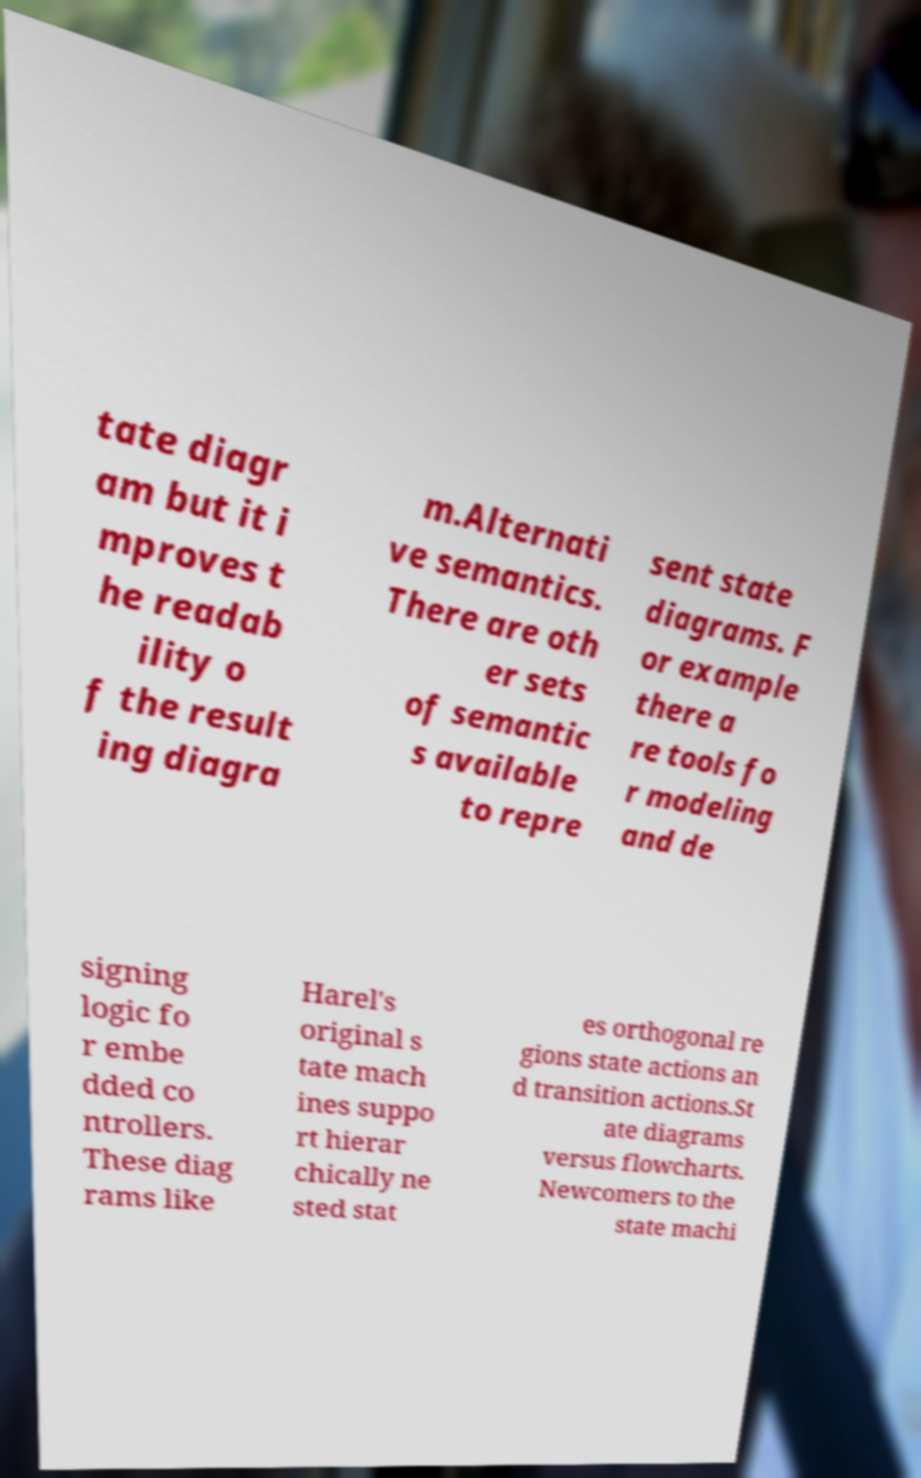For documentation purposes, I need the text within this image transcribed. Could you provide that? tate diagr am but it i mproves t he readab ility o f the result ing diagra m.Alternati ve semantics. There are oth er sets of semantic s available to repre sent state diagrams. F or example there a re tools fo r modeling and de signing logic fo r embe dded co ntrollers. These diag rams like Harel's original s tate mach ines suppo rt hierar chically ne sted stat es orthogonal re gions state actions an d transition actions.St ate diagrams versus flowcharts. Newcomers to the state machi 